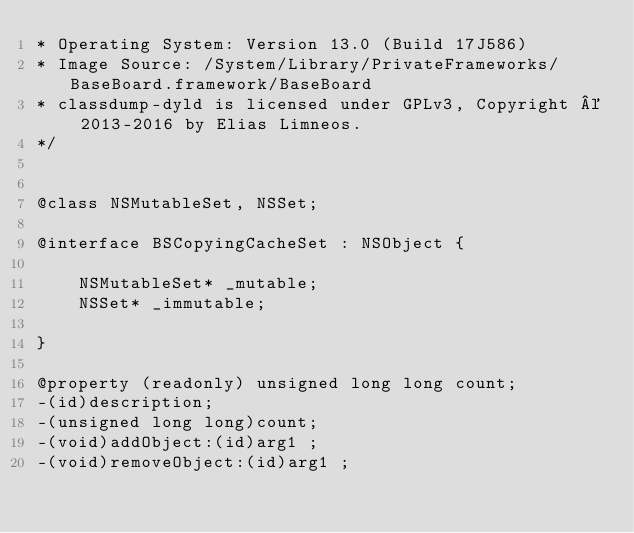Convert code to text. <code><loc_0><loc_0><loc_500><loc_500><_C_>* Operating System: Version 13.0 (Build 17J586)
* Image Source: /System/Library/PrivateFrameworks/BaseBoard.framework/BaseBoard
* classdump-dyld is licensed under GPLv3, Copyright © 2013-2016 by Elias Limneos.
*/


@class NSMutableSet, NSSet;

@interface BSCopyingCacheSet : NSObject {

	NSMutableSet* _mutable;
	NSSet* _immutable;

}

@property (readonly) unsigned long long count; 
-(id)description;
-(unsigned long long)count;
-(void)addObject:(id)arg1 ;
-(void)removeObject:(id)arg1 ;</code> 